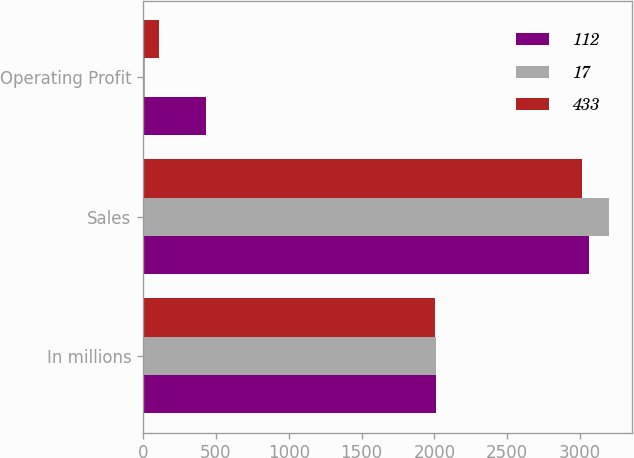Convert chart to OTSL. <chart><loc_0><loc_0><loc_500><loc_500><stacked_bar_chart><ecel><fcel>In millions<fcel>Sales<fcel>Operating Profit<nl><fcel>112<fcel>2009<fcel>3060<fcel>433<nl><fcel>17<fcel>2008<fcel>3195<fcel>17<nl><fcel>433<fcel>2007<fcel>3015<fcel>112<nl></chart> 